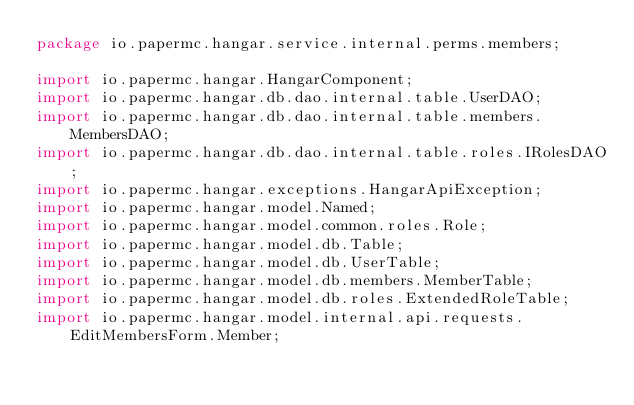Convert code to text. <code><loc_0><loc_0><loc_500><loc_500><_Java_>package io.papermc.hangar.service.internal.perms.members;

import io.papermc.hangar.HangarComponent;
import io.papermc.hangar.db.dao.internal.table.UserDAO;
import io.papermc.hangar.db.dao.internal.table.members.MembersDAO;
import io.papermc.hangar.db.dao.internal.table.roles.IRolesDAO;
import io.papermc.hangar.exceptions.HangarApiException;
import io.papermc.hangar.model.Named;
import io.papermc.hangar.model.common.roles.Role;
import io.papermc.hangar.model.db.Table;
import io.papermc.hangar.model.db.UserTable;
import io.papermc.hangar.model.db.members.MemberTable;
import io.papermc.hangar.model.db.roles.ExtendedRoleTable;
import io.papermc.hangar.model.internal.api.requests.EditMembersForm.Member;</code> 